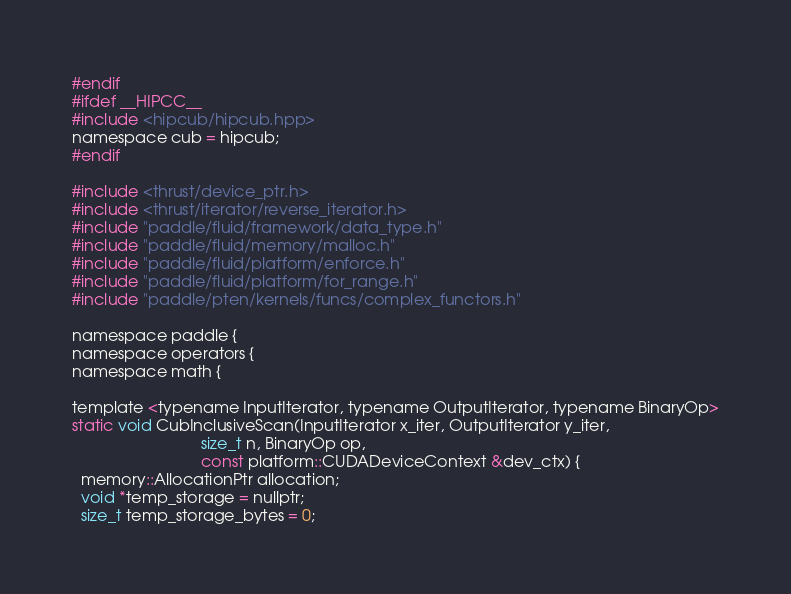<code> <loc_0><loc_0><loc_500><loc_500><_C_>#endif
#ifdef __HIPCC__
#include <hipcub/hipcub.hpp>
namespace cub = hipcub;
#endif

#include <thrust/device_ptr.h>
#include <thrust/iterator/reverse_iterator.h>
#include "paddle/fluid/framework/data_type.h"
#include "paddle/fluid/memory/malloc.h"
#include "paddle/fluid/platform/enforce.h"
#include "paddle/fluid/platform/for_range.h"
#include "paddle/pten/kernels/funcs/complex_functors.h"

namespace paddle {
namespace operators {
namespace math {

template <typename InputIterator, typename OutputIterator, typename BinaryOp>
static void CubInclusiveScan(InputIterator x_iter, OutputIterator y_iter,
                             size_t n, BinaryOp op,
                             const platform::CUDADeviceContext &dev_ctx) {
  memory::AllocationPtr allocation;
  void *temp_storage = nullptr;
  size_t temp_storage_bytes = 0;</code> 